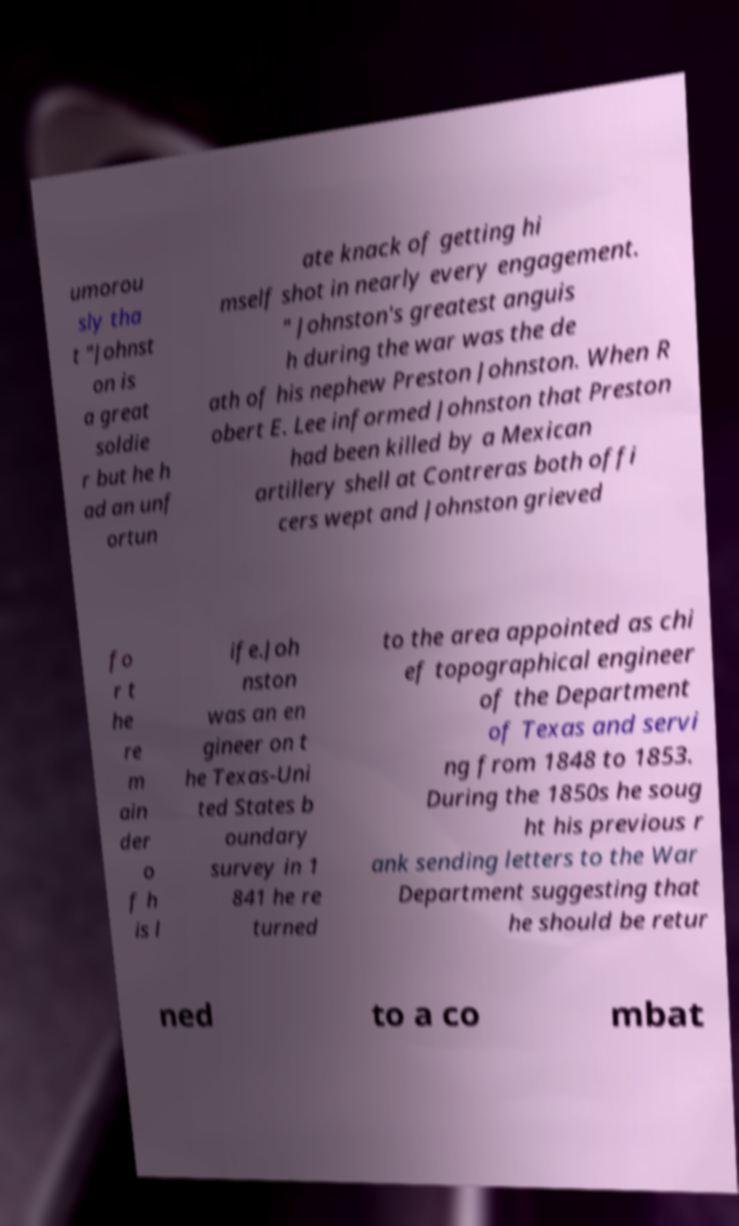What messages or text are displayed in this image? I need them in a readable, typed format. umorou sly tha t "Johnst on is a great soldie r but he h ad an unf ortun ate knack of getting hi mself shot in nearly every engagement. " Johnston's greatest anguis h during the war was the de ath of his nephew Preston Johnston. When R obert E. Lee informed Johnston that Preston had been killed by a Mexican artillery shell at Contreras both offi cers wept and Johnston grieved fo r t he re m ain der o f h is l ife.Joh nston was an en gineer on t he Texas-Uni ted States b oundary survey in 1 841 he re turned to the area appointed as chi ef topographical engineer of the Department of Texas and servi ng from 1848 to 1853. During the 1850s he soug ht his previous r ank sending letters to the War Department suggesting that he should be retur ned to a co mbat 